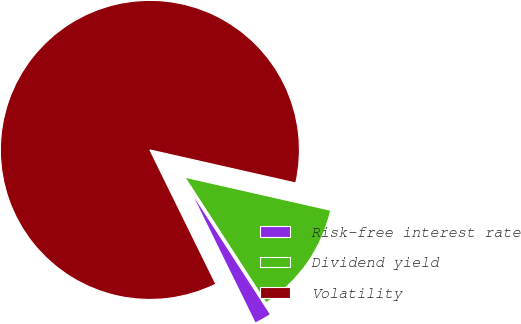Convert chart. <chart><loc_0><loc_0><loc_500><loc_500><pie_chart><fcel>Risk-free interest rate<fcel>Dividend yield<fcel>Volatility<nl><fcel>1.87%<fcel>12.31%<fcel>85.82%<nl></chart> 